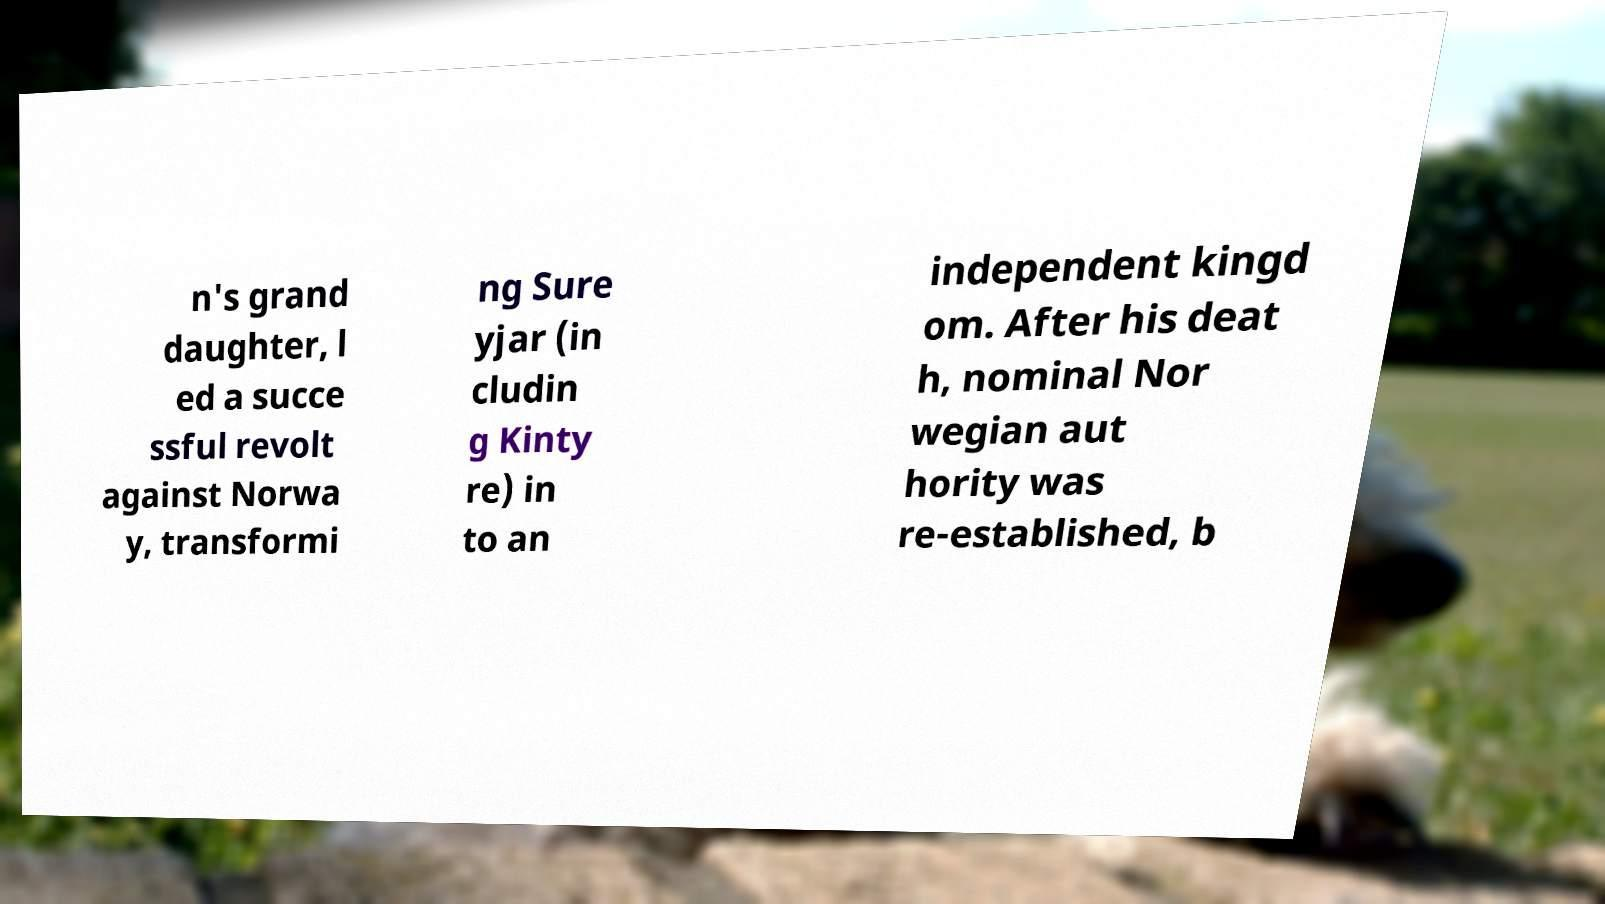Could you assist in decoding the text presented in this image and type it out clearly? n's grand daughter, l ed a succe ssful revolt against Norwa y, transformi ng Sure yjar (in cludin g Kinty re) in to an independent kingd om. After his deat h, nominal Nor wegian aut hority was re-established, b 